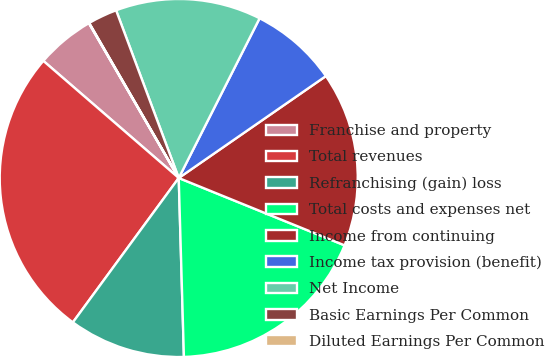<chart> <loc_0><loc_0><loc_500><loc_500><pie_chart><fcel>Franchise and property<fcel>Total revenues<fcel>Refranchising (gain) loss<fcel>Total costs and expenses net<fcel>Income from continuing<fcel>Income tax provision (benefit)<fcel>Net Income<fcel>Basic Earnings Per Common<fcel>Diluted Earnings Per Common<nl><fcel>5.28%<fcel>26.28%<fcel>10.53%<fcel>18.4%<fcel>15.78%<fcel>7.9%<fcel>13.15%<fcel>2.65%<fcel>0.03%<nl></chart> 